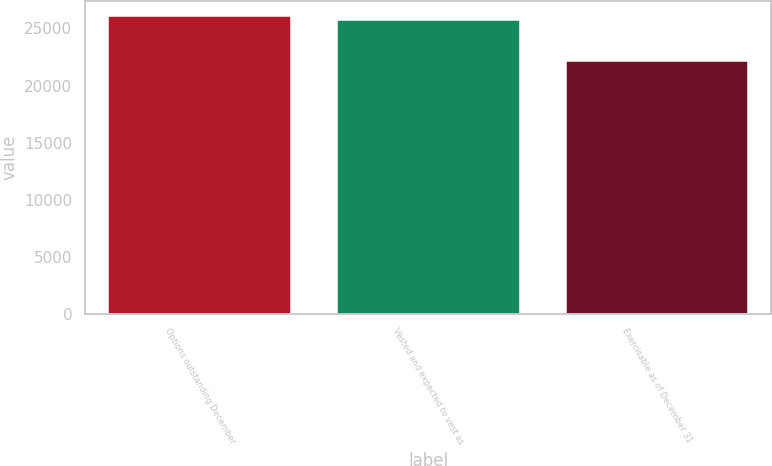Convert chart to OTSL. <chart><loc_0><loc_0><loc_500><loc_500><bar_chart><fcel>Options outstanding December<fcel>Vested and expected to vest as<fcel>Exercisable as of December 31<nl><fcel>26138.3<fcel>25772<fcel>22140<nl></chart> 